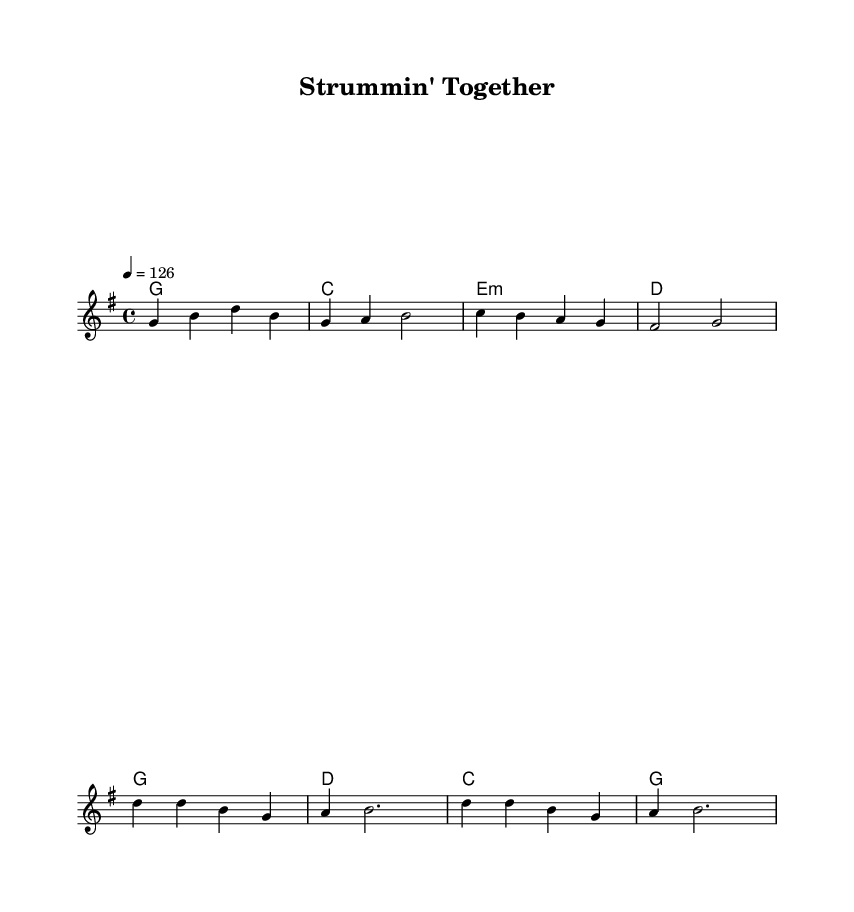What is the key signature of this music? The key signature is indicated at the beginning of the staff and shows one sharp, which corresponds to G major.
Answer: G major What is the time signature of the piece? The time signature, located after the key signature, is 4/4, meaning there are four beats in each measure and the quarter note gets one beat.
Answer: 4/4 What is the tempo marking for this song? The tempo marking is shown as '4 = 126', meaning there are 126 quarter note beats per minute, indicating a brisk pace for this upbeat country rock anthem.
Answer: 126 How many measures are in the verse? Counting the measures in the verse section of the sheet music, there are four measures of music specified.
Answer: 4 What chord is played in the second measure of the verse? Referring to the harmonies above the melody, the second measure of the verse shows a C chord being played.
Answer: C What is the theme of the chorus lyrics? By examining the chorus lyrics, they express a sense of camaraderie and dedication to making music together, typical of country rock anthems celebrating collaboration.
Answer: Making music forever What style of music does "Strummin' Together" represent? The style of this piece can be identified by its upbeat tempo, lyrical content about collaboration, and use of traditional chords, aligning it with the characteristics of country rock.
Answer: Country rock 